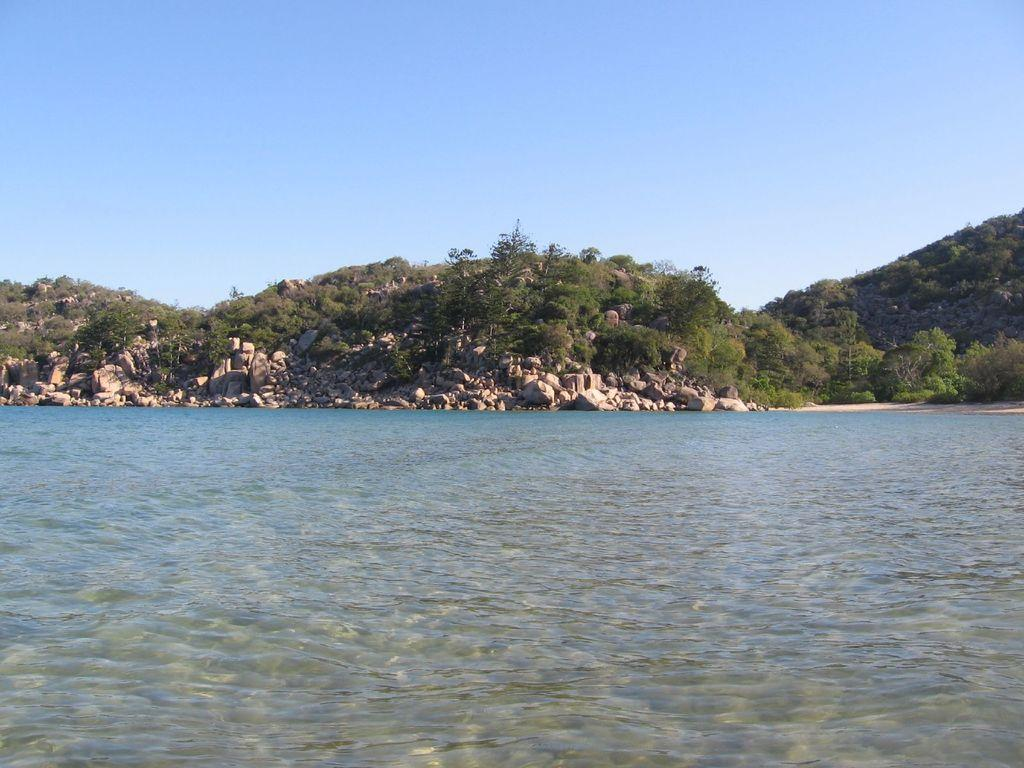What type of natural elements can be seen in the image? There are trees, hills, rocks, and water visible in the image. What is the background of the image? The sky is visible in the background of the image. Can you describe the terrain in the image? The terrain in the image includes hills and rocks. How many different types of natural elements are present in the image? There are five different types of natural elements present in the image: trees, hills, rocks, water, and sky. Can you see any instances of people exchanging kisses in the image? There are no people or any indication of exchanging kisses present in the image. 